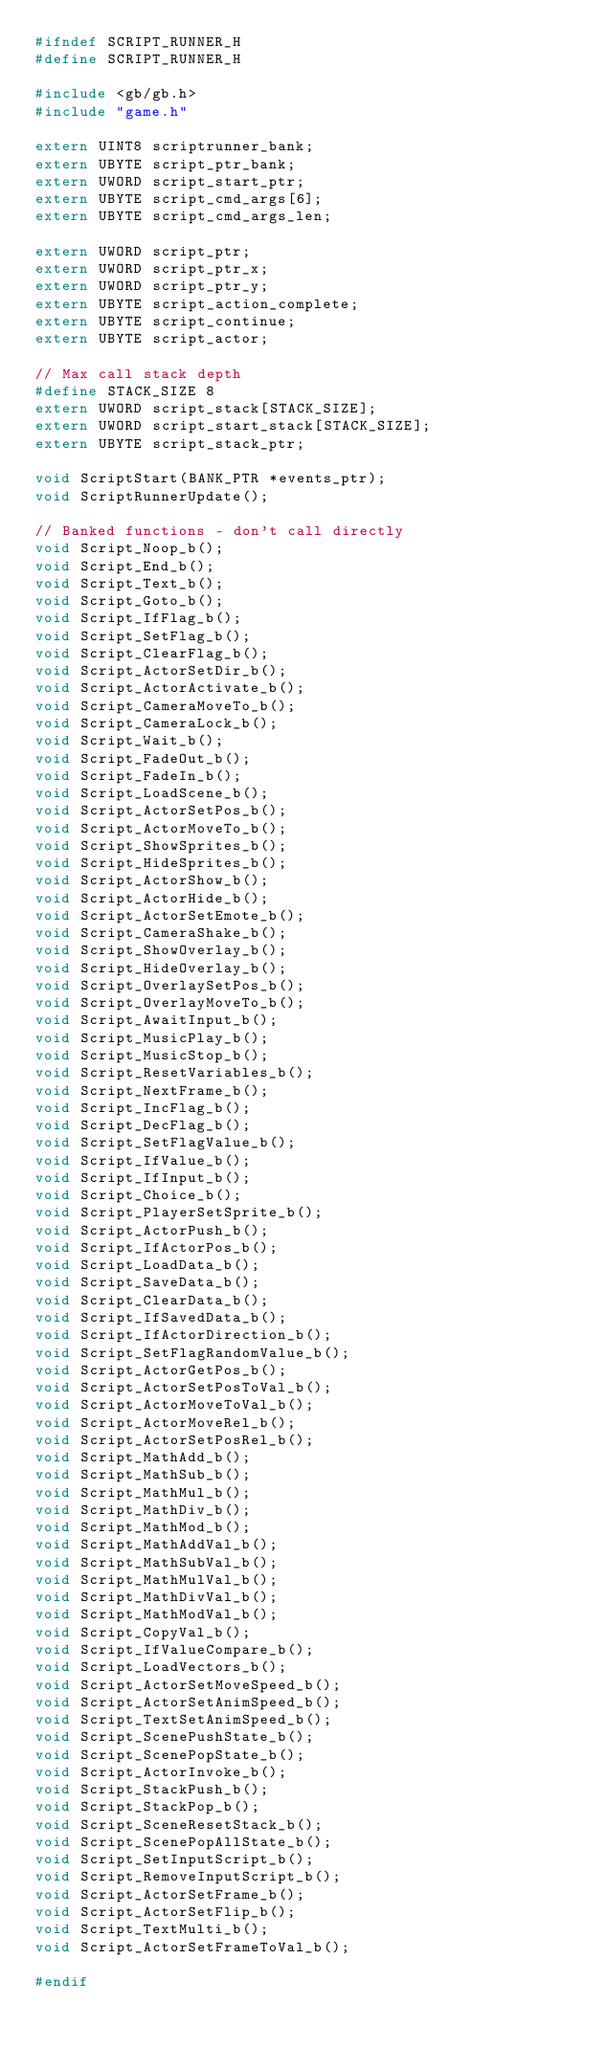Convert code to text. <code><loc_0><loc_0><loc_500><loc_500><_C_>#ifndef SCRIPT_RUNNER_H
#define SCRIPT_RUNNER_H

#include <gb/gb.h>
#include "game.h"

extern UINT8 scriptrunner_bank;
extern UBYTE script_ptr_bank;
extern UWORD script_start_ptr;
extern UBYTE script_cmd_args[6];
extern UBYTE script_cmd_args_len;

extern UWORD script_ptr;
extern UWORD script_ptr_x;
extern UWORD script_ptr_y;
extern UBYTE script_action_complete;
extern UBYTE script_continue;
extern UBYTE script_actor;

// Max call stack depth
#define STACK_SIZE 8
extern UWORD script_stack[STACK_SIZE];
extern UWORD script_start_stack[STACK_SIZE];
extern UBYTE script_stack_ptr;

void ScriptStart(BANK_PTR *events_ptr);
void ScriptRunnerUpdate();

// Banked functions - don't call directly
void Script_Noop_b();
void Script_End_b();
void Script_Text_b();
void Script_Goto_b();
void Script_IfFlag_b();
void Script_SetFlag_b();
void Script_ClearFlag_b();
void Script_ActorSetDir_b();
void Script_ActorActivate_b();
void Script_CameraMoveTo_b();
void Script_CameraLock_b();
void Script_Wait_b();
void Script_FadeOut_b();
void Script_FadeIn_b();
void Script_LoadScene_b();
void Script_ActorSetPos_b();
void Script_ActorMoveTo_b();
void Script_ShowSprites_b();
void Script_HideSprites_b();
void Script_ActorShow_b();
void Script_ActorHide_b();
void Script_ActorSetEmote_b();
void Script_CameraShake_b();
void Script_ShowOverlay_b();
void Script_HideOverlay_b();
void Script_OverlaySetPos_b();
void Script_OverlayMoveTo_b();
void Script_AwaitInput_b();
void Script_MusicPlay_b();
void Script_MusicStop_b();
void Script_ResetVariables_b();
void Script_NextFrame_b();
void Script_IncFlag_b();
void Script_DecFlag_b();
void Script_SetFlagValue_b();
void Script_IfValue_b();
void Script_IfInput_b();
void Script_Choice_b();
void Script_PlayerSetSprite_b();
void Script_ActorPush_b();
void Script_IfActorPos_b();
void Script_LoadData_b();
void Script_SaveData_b();
void Script_ClearData_b();
void Script_IfSavedData_b();
void Script_IfActorDirection_b();
void Script_SetFlagRandomValue_b();
void Script_ActorGetPos_b();
void Script_ActorSetPosToVal_b();
void Script_ActorMoveToVal_b();
void Script_ActorMoveRel_b();
void Script_ActorSetPosRel_b();
void Script_MathAdd_b();
void Script_MathSub_b();
void Script_MathMul_b();
void Script_MathDiv_b();
void Script_MathMod_b();
void Script_MathAddVal_b();
void Script_MathSubVal_b();
void Script_MathMulVal_b();
void Script_MathDivVal_b();
void Script_MathModVal_b();
void Script_CopyVal_b();
void Script_IfValueCompare_b();
void Script_LoadVectors_b();
void Script_ActorSetMoveSpeed_b();
void Script_ActorSetAnimSpeed_b();
void Script_TextSetAnimSpeed_b();
void Script_ScenePushState_b();
void Script_ScenePopState_b();
void Script_ActorInvoke_b();
void Script_StackPush_b();
void Script_StackPop_b();
void Script_SceneResetStack_b();
void Script_ScenePopAllState_b();
void Script_SetInputScript_b();
void Script_RemoveInputScript_b();
void Script_ActorSetFrame_b();
void Script_ActorSetFlip_b();
void Script_TextMulti_b();
void Script_ActorSetFrameToVal_b();

#endif
</code> 